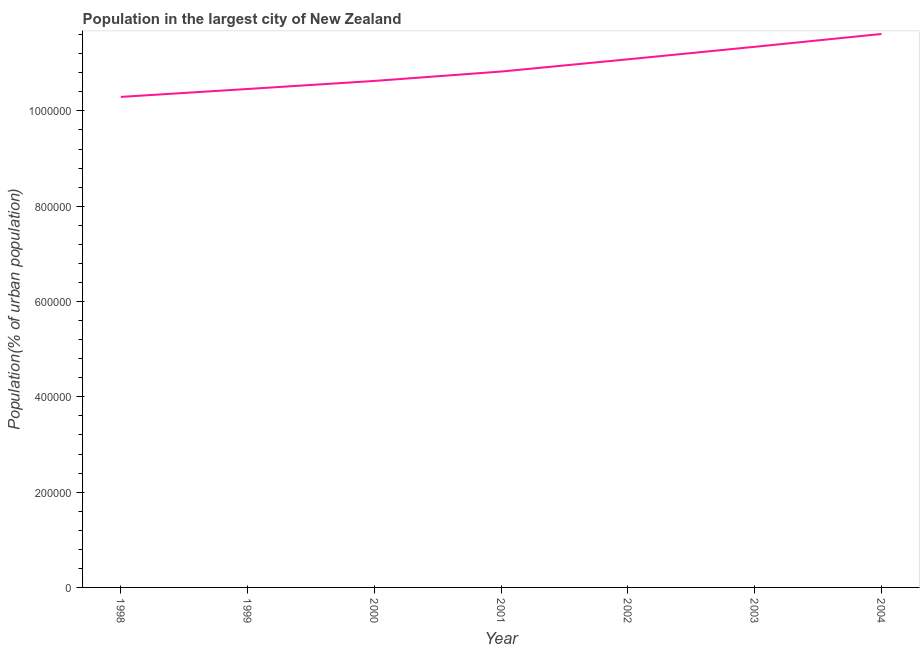What is the population in largest city in 2000?
Your answer should be very brief. 1.06e+06. Across all years, what is the maximum population in largest city?
Your answer should be compact. 1.16e+06. Across all years, what is the minimum population in largest city?
Give a very brief answer. 1.03e+06. What is the sum of the population in largest city?
Make the answer very short. 7.63e+06. What is the difference between the population in largest city in 1998 and 2003?
Provide a short and direct response. -1.05e+05. What is the average population in largest city per year?
Offer a terse response. 1.09e+06. What is the median population in largest city?
Make the answer very short. 1.08e+06. In how many years, is the population in largest city greater than 640000 %?
Provide a short and direct response. 7. Do a majority of the years between 1999 and 2000 (inclusive) have population in largest city greater than 240000 %?
Give a very brief answer. Yes. What is the ratio of the population in largest city in 1998 to that in 2002?
Your answer should be compact. 0.93. What is the difference between the highest and the second highest population in largest city?
Your answer should be compact. 2.69e+04. Is the sum of the population in largest city in 2001 and 2004 greater than the maximum population in largest city across all years?
Your response must be concise. Yes. What is the difference between the highest and the lowest population in largest city?
Ensure brevity in your answer.  1.32e+05. How many lines are there?
Your answer should be compact. 1. How many years are there in the graph?
Your answer should be very brief. 7. What is the difference between two consecutive major ticks on the Y-axis?
Your answer should be very brief. 2.00e+05. Are the values on the major ticks of Y-axis written in scientific E-notation?
Your answer should be compact. No. Does the graph contain any zero values?
Provide a short and direct response. No. Does the graph contain grids?
Ensure brevity in your answer.  No. What is the title of the graph?
Keep it short and to the point. Population in the largest city of New Zealand. What is the label or title of the Y-axis?
Your response must be concise. Population(% of urban population). What is the Population(% of urban population) in 1998?
Provide a succinct answer. 1.03e+06. What is the Population(% of urban population) in 1999?
Provide a succinct answer. 1.05e+06. What is the Population(% of urban population) of 2000?
Keep it short and to the point. 1.06e+06. What is the Population(% of urban population) of 2001?
Give a very brief answer. 1.08e+06. What is the Population(% of urban population) of 2002?
Your answer should be compact. 1.11e+06. What is the Population(% of urban population) of 2003?
Offer a very short reply. 1.13e+06. What is the Population(% of urban population) of 2004?
Make the answer very short. 1.16e+06. What is the difference between the Population(% of urban population) in 1998 and 1999?
Your response must be concise. -1.66e+04. What is the difference between the Population(% of urban population) in 1998 and 2000?
Give a very brief answer. -3.35e+04. What is the difference between the Population(% of urban population) in 1998 and 2001?
Keep it short and to the point. -5.32e+04. What is the difference between the Population(% of urban population) in 1998 and 2002?
Provide a short and direct response. -7.89e+04. What is the difference between the Population(% of urban population) in 1998 and 2003?
Ensure brevity in your answer.  -1.05e+05. What is the difference between the Population(% of urban population) in 1998 and 2004?
Ensure brevity in your answer.  -1.32e+05. What is the difference between the Population(% of urban population) in 1999 and 2000?
Give a very brief answer. -1.69e+04. What is the difference between the Population(% of urban population) in 1999 and 2001?
Your answer should be very brief. -3.66e+04. What is the difference between the Population(% of urban population) in 1999 and 2002?
Ensure brevity in your answer.  -6.23e+04. What is the difference between the Population(% of urban population) in 1999 and 2003?
Offer a terse response. -8.85e+04. What is the difference between the Population(% of urban population) in 1999 and 2004?
Offer a very short reply. -1.15e+05. What is the difference between the Population(% of urban population) in 2000 and 2001?
Your answer should be compact. -1.97e+04. What is the difference between the Population(% of urban population) in 2000 and 2002?
Provide a succinct answer. -4.54e+04. What is the difference between the Population(% of urban population) in 2000 and 2003?
Keep it short and to the point. -7.16e+04. What is the difference between the Population(% of urban population) in 2000 and 2004?
Offer a terse response. -9.86e+04. What is the difference between the Population(% of urban population) in 2001 and 2002?
Keep it short and to the point. -2.57e+04. What is the difference between the Population(% of urban population) in 2001 and 2003?
Make the answer very short. -5.19e+04. What is the difference between the Population(% of urban population) in 2001 and 2004?
Your answer should be compact. -7.88e+04. What is the difference between the Population(% of urban population) in 2002 and 2003?
Provide a short and direct response. -2.63e+04. What is the difference between the Population(% of urban population) in 2002 and 2004?
Ensure brevity in your answer.  -5.32e+04. What is the difference between the Population(% of urban population) in 2003 and 2004?
Your answer should be very brief. -2.69e+04. What is the ratio of the Population(% of urban population) in 1998 to that in 1999?
Your answer should be very brief. 0.98. What is the ratio of the Population(% of urban population) in 1998 to that in 2000?
Your response must be concise. 0.97. What is the ratio of the Population(% of urban population) in 1998 to that in 2001?
Make the answer very short. 0.95. What is the ratio of the Population(% of urban population) in 1998 to that in 2002?
Keep it short and to the point. 0.93. What is the ratio of the Population(% of urban population) in 1998 to that in 2003?
Provide a succinct answer. 0.91. What is the ratio of the Population(% of urban population) in 1998 to that in 2004?
Make the answer very short. 0.89. What is the ratio of the Population(% of urban population) in 1999 to that in 2000?
Your response must be concise. 0.98. What is the ratio of the Population(% of urban population) in 1999 to that in 2002?
Your answer should be very brief. 0.94. What is the ratio of the Population(% of urban population) in 1999 to that in 2003?
Your answer should be compact. 0.92. What is the ratio of the Population(% of urban population) in 1999 to that in 2004?
Make the answer very short. 0.9. What is the ratio of the Population(% of urban population) in 2000 to that in 2001?
Offer a very short reply. 0.98. What is the ratio of the Population(% of urban population) in 2000 to that in 2003?
Your answer should be very brief. 0.94. What is the ratio of the Population(% of urban population) in 2000 to that in 2004?
Keep it short and to the point. 0.92. What is the ratio of the Population(% of urban population) in 2001 to that in 2003?
Provide a short and direct response. 0.95. What is the ratio of the Population(% of urban population) in 2001 to that in 2004?
Your answer should be compact. 0.93. What is the ratio of the Population(% of urban population) in 2002 to that in 2003?
Keep it short and to the point. 0.98. What is the ratio of the Population(% of urban population) in 2002 to that in 2004?
Your response must be concise. 0.95. 